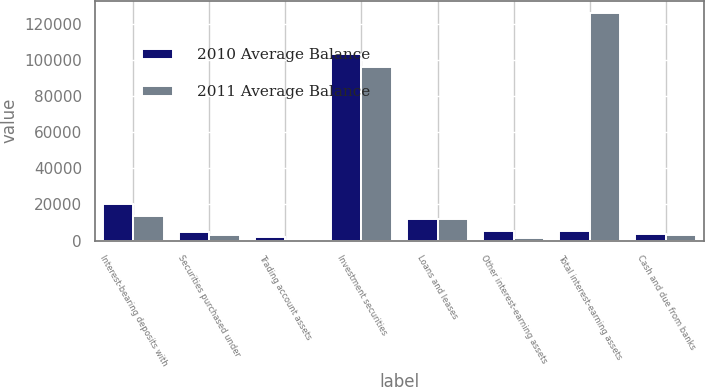Convert chart. <chart><loc_0><loc_0><loc_500><loc_500><stacked_bar_chart><ecel><fcel>Interest-bearing deposits with<fcel>Securities purchased under<fcel>Trading account assets<fcel>Investment securities<fcel>Loans and leases<fcel>Other interest-earning assets<fcel>Total interest-earning assets<fcel>Cash and due from banks<nl><fcel>2010 Average Balance<fcel>20241<fcel>4686<fcel>2013<fcel>103075<fcel>12180<fcel>5462<fcel>5462<fcel>3436<nl><fcel>2011 Average Balance<fcel>13550<fcel>2957<fcel>376<fcel>96123<fcel>12094<fcel>1156<fcel>126256<fcel>2781<nl></chart> 